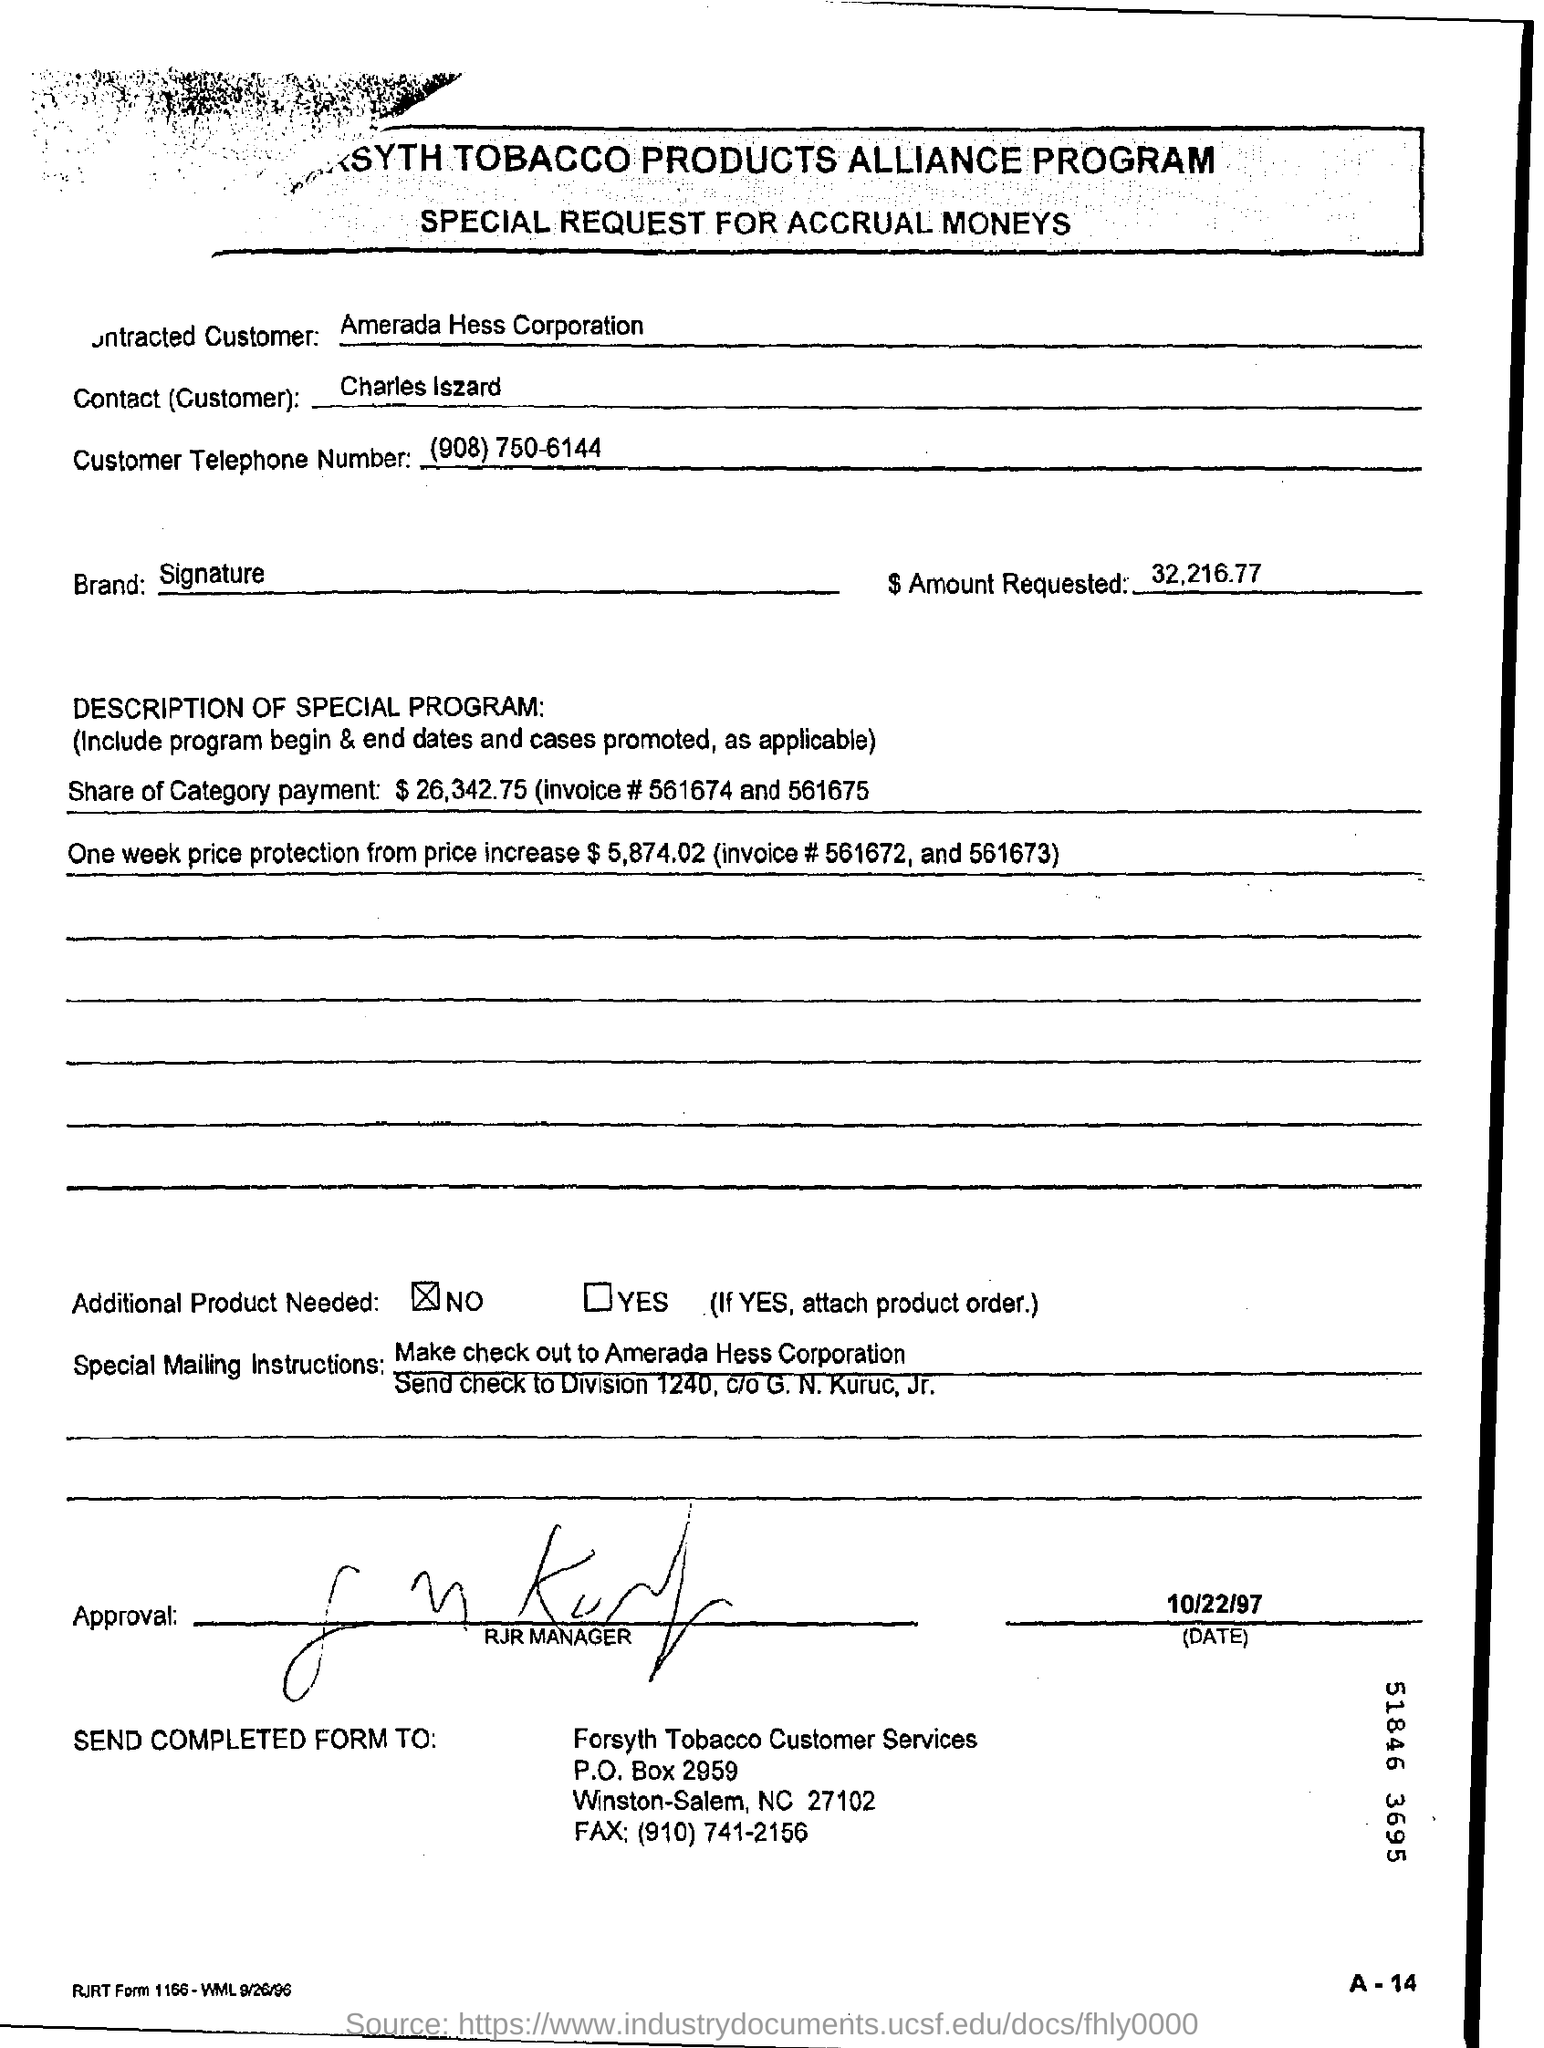List a handful of essential elements in this visual. The customer mentioned in the form is Charles Iszard. The P.O. Box number of Forsyth tobacco customer services is P.O. Box 2959. The name of the contact is Charles Iszard. Is the additional product needed checked? No. Amerada Hess Corporation is the contracted customer. 